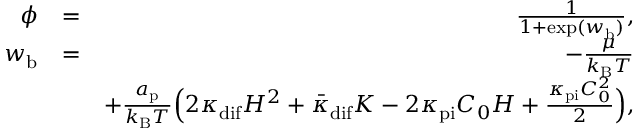Convert formula to latex. <formula><loc_0><loc_0><loc_500><loc_500>\begin{array} { r l r } { \phi } & { = } & { \frac { 1 } { 1 + \exp ( w _ { b } ) } , } \\ { w _ { b } } & { = } & { - \frac { \mu } { k _ { B } T } } \\ & { + \frac { a _ { p } } { k _ { B } T } \left ( 2 \kappa _ { d i f } H ^ { 2 } + \bar { \kappa } _ { d i f } K - 2 \kappa _ { p i } C _ { 0 } H + \frac { \kappa _ { p i } C _ { 0 } ^ { 2 } } { 2 } \right ) , } \end{array}</formula> 